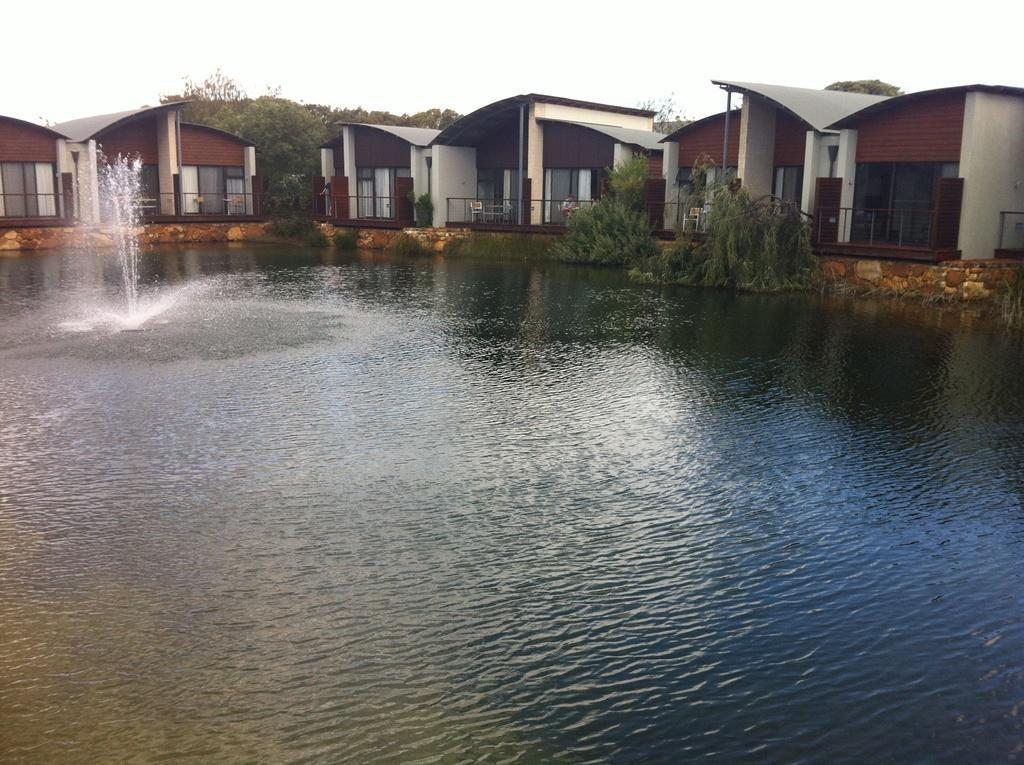Describe this image in one or two sentences. In the picture we can see water, and far away from it, we can see some planets, houses and sky. 